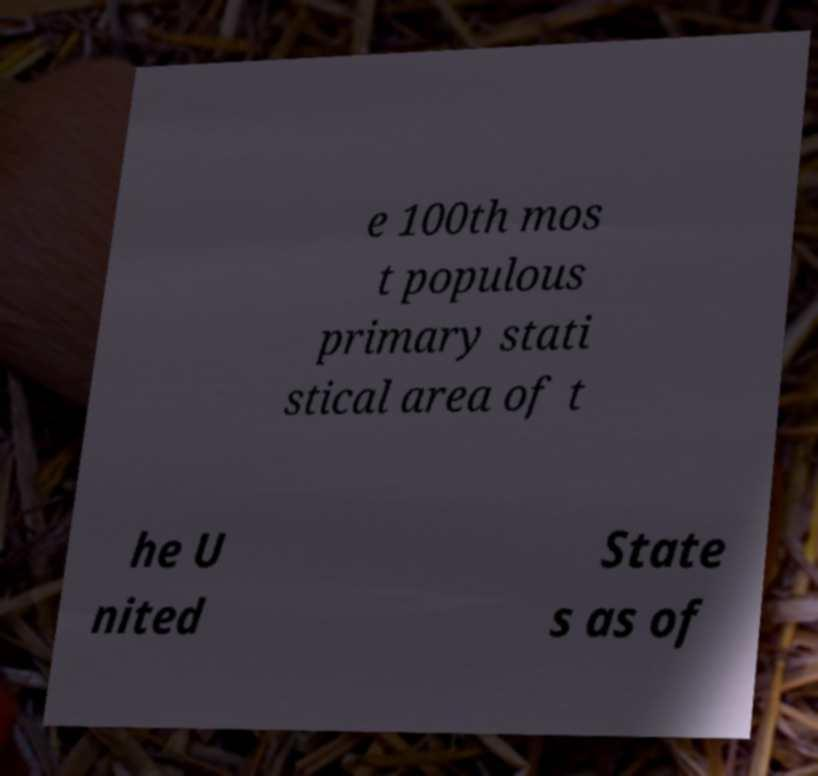Can you accurately transcribe the text from the provided image for me? e 100th mos t populous primary stati stical area of t he U nited State s as of 